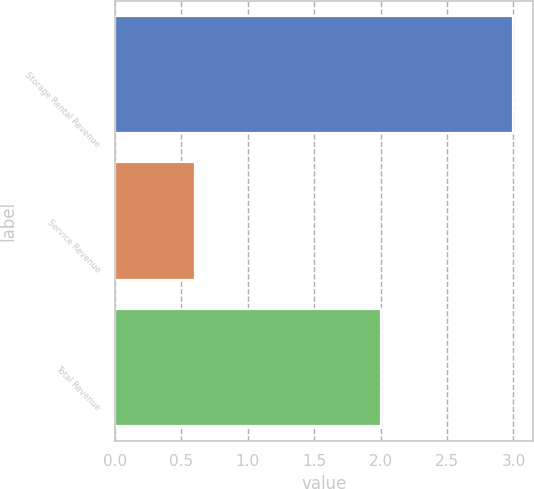Convert chart. <chart><loc_0><loc_0><loc_500><loc_500><bar_chart><fcel>Storage Rental Revenue<fcel>Service Revenue<fcel>Total Revenue<nl><fcel>3<fcel>0.6<fcel>2<nl></chart> 